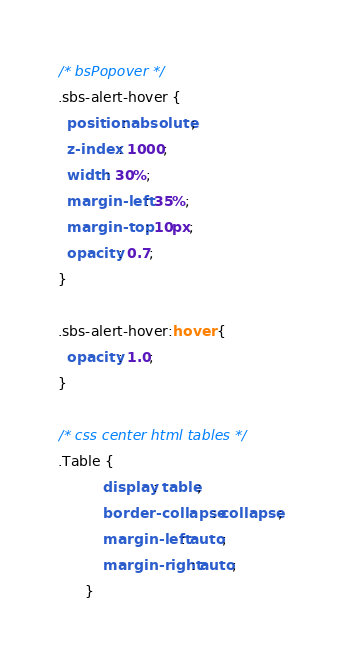Convert code to text. <code><loc_0><loc_0><loc_500><loc_500><_CSS_>/* bsPopover */
.sbs-alert-hover {
  position: absolute;
  z-index: 1000;
  width: 30%;
  margin-left: 35%;
  margin-top: 10px;
  opacity: 0.7;
}

.sbs-alert-hover:hover {
  opacity: 1.0;
}

/* css center html tables */
.Table {
          display: table;
          border-collapse: collapse;
          margin-left: auto;
          margin-right: auto;
      }
</code> 